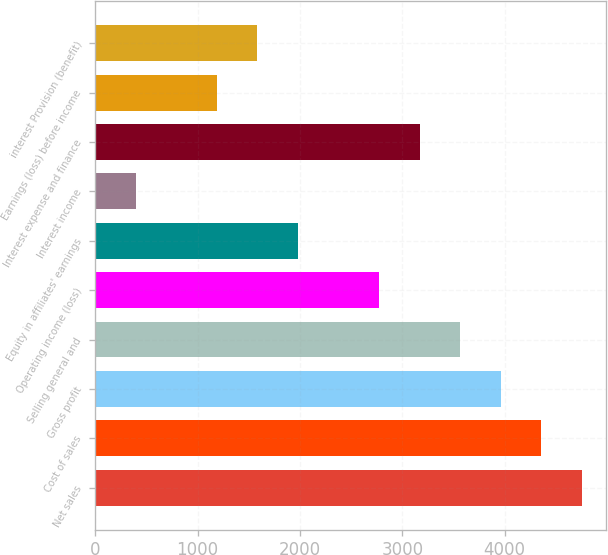<chart> <loc_0><loc_0><loc_500><loc_500><bar_chart><fcel>Net sales<fcel>Cost of sales<fcel>Gross profit<fcel>Selling general and<fcel>Operating income (loss)<fcel>Equity in affiliates' earnings<fcel>Interest income<fcel>Interest expense and finance<fcel>Earnings (loss) before income<fcel>interest Provision (benefit)<nl><fcel>4754.15<fcel>4357.99<fcel>3961.83<fcel>3565.67<fcel>2773.35<fcel>1981.03<fcel>396.39<fcel>3169.51<fcel>1188.71<fcel>1584.87<nl></chart> 